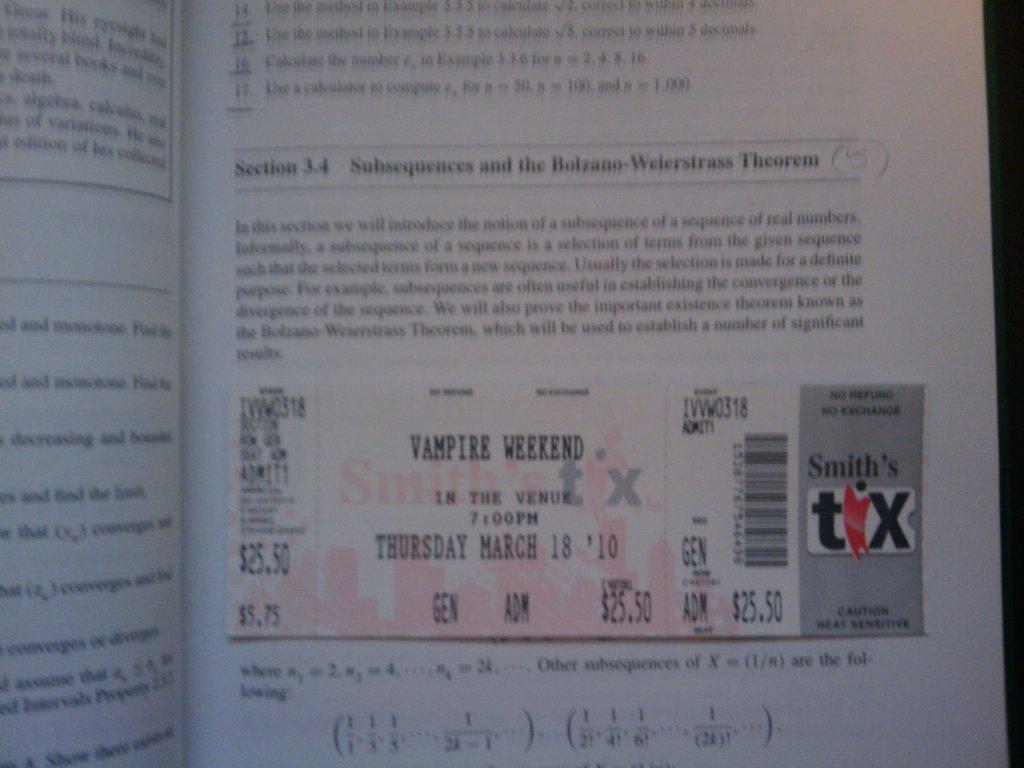How would you summarize this image in a sentence or two? In this image, we can see a page contains a coupon and some text. 